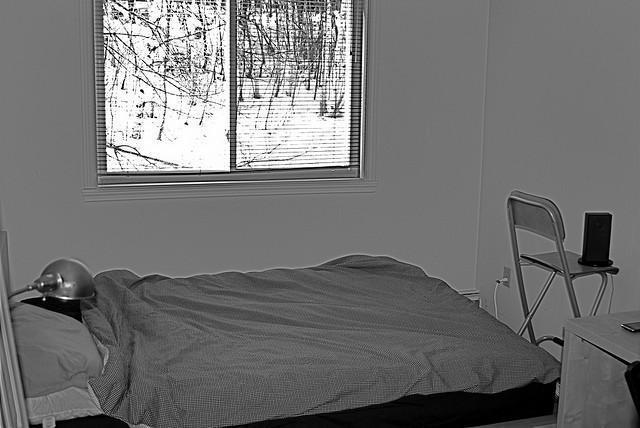How many giraffes are there?
Give a very brief answer. 0. 